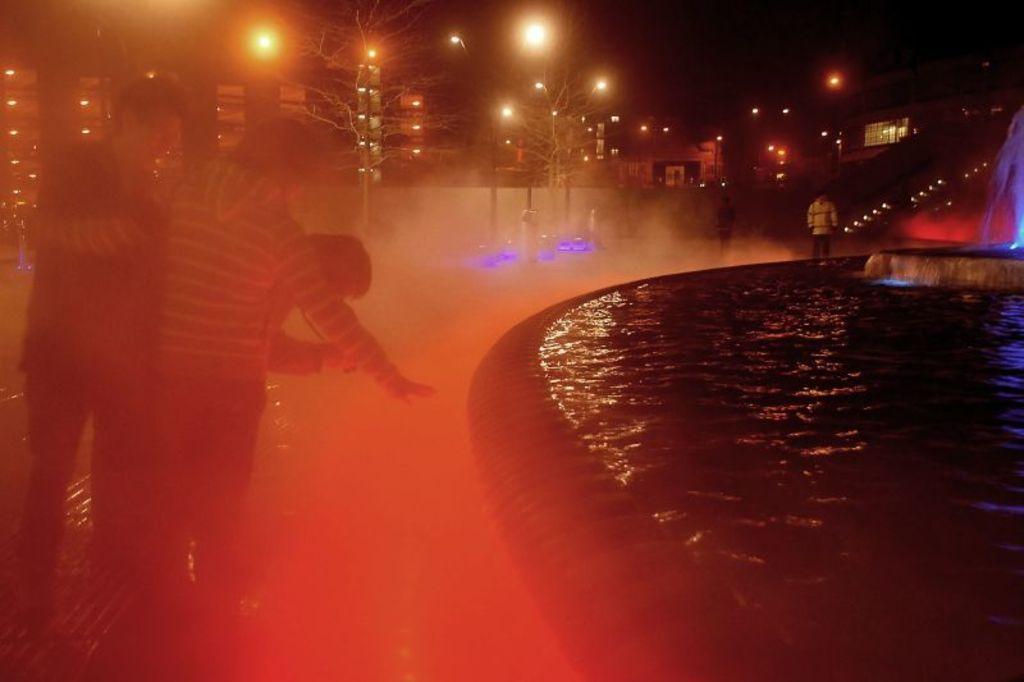What is the main feature in the image? There is a water fountain in the image. Are there any people present in the image? Yes, there are people standing in the image. What structures can be seen in the image besides the water fountain? There are light poles in the image. Can you describe the lighting in the image? There are lights in the image. What type of scarf is the bear wearing in the image? There is no bear or scarf present in the image. How does the beggar interact with the water fountain in the image? There is no beggar present in the image, and therefore no interaction with the water fountain can be observed. 